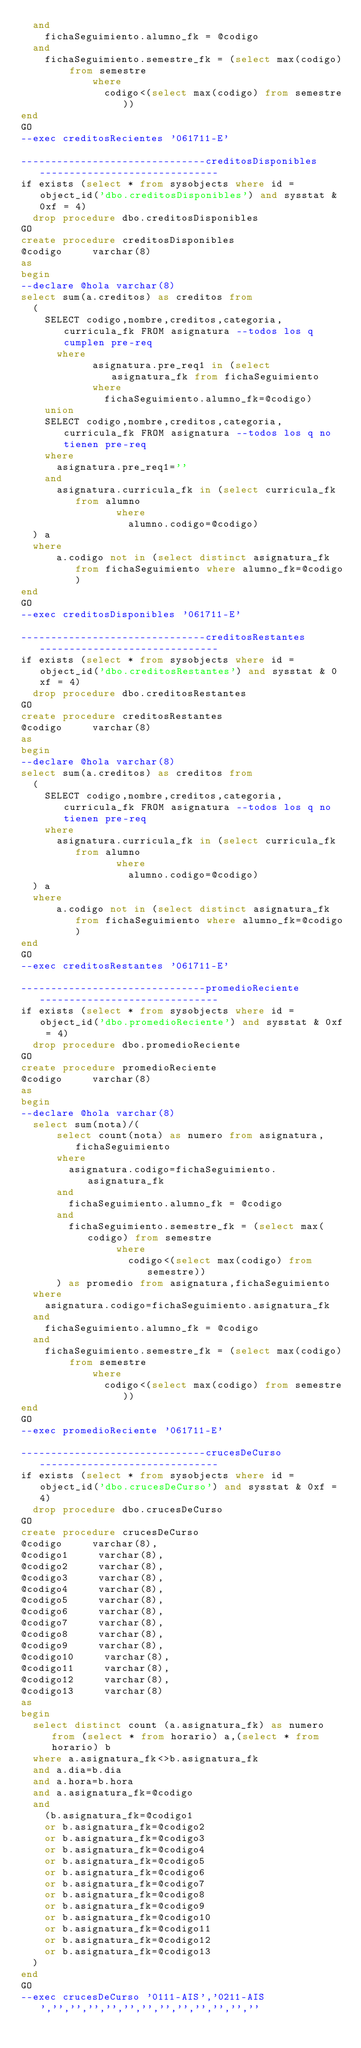Convert code to text. <code><loc_0><loc_0><loc_500><loc_500><_SQL_>	and 
		fichaSeguimiento.alumno_fk = @codigo
	and
		fichaSeguimiento.semestre_fk = (select max(codigo) from semestre
						where 
							codigo<(select max(codigo) from semestre))
end
GO
--exec creditosRecientes '061711-E'

-------------------------------creditosDisponibles------------------------------
if exists (select * from sysobjects where id = object_id('dbo.creditosDisponibles') and sysstat & 0xf = 4) 
  drop procedure dbo.creditosDisponibles
GO
create procedure creditosDisponibles
@codigo     varchar(8)
as
begin
--declare @hola varchar(8)
select sum(a.creditos) as creditos from 
	(
		SELECT codigo,nombre,creditos,categoria,curricula_fk FROM asignatura --todos los q cumplen pre-req
  		where 
        		asignatura.pre_req1 in (select asignatura_fk from fichaSeguimiento
						where
							fichaSeguimiento.alumno_fk=@codigo)
		union
		SELECT codigo,nombre,creditos,categoria,curricula_fk FROM asignatura --todos los q no tienen pre-req
		where 
			asignatura.pre_req1='' 
		and 
			asignatura.curricula_fk in (select curricula_fk from alumno
						    where
						    	alumno.codigo=@codigo)
	) a
	where
  		a.codigo not in (select distinct asignatura_fk from fichaSeguimiento where alumno_fk=@codigo)
end
GO
--exec creditosDisponibles '061711-E'

-------------------------------creditosRestantes------------------------------
if exists (select * from sysobjects where id = object_id('dbo.creditosRestantes') and sysstat & 0xf = 4) 
  drop procedure dbo.creditosRestantes
GO
create procedure creditosRestantes
@codigo     varchar(8)
as
begin
--declare @hola varchar(8)
select sum(a.creditos) as creditos from 
	(
		SELECT codigo,nombre,creditos,categoria,curricula_fk FROM asignatura --todos los q no tienen pre-req
		where
			asignatura.curricula_fk in (select curricula_fk from alumno
						    where
						    	alumno.codigo=@codigo)
	) a
	where
  		a.codigo not in (select distinct asignatura_fk from fichaSeguimiento where alumno_fk=@codigo)
end
GO
--exec creditosRestantes '061711-E'

-------------------------------promedioReciente------------------------------
if exists (select * from sysobjects where id = object_id('dbo.promedioReciente') and sysstat & 0xf = 4) 
  drop procedure dbo.promedioReciente
GO
create procedure promedioReciente
@codigo     varchar(8)
as
begin
--declare @hola varchar(8)
	select sum(nota)/(
			select count(nota) as numero from asignatura,fichaSeguimiento 
			where 
				asignatura.codigo=fichaSeguimiento.asignatura_fk 
			and 
				fichaSeguimiento.alumno_fk = @codigo
			and
				fichaSeguimiento.semestre_fk = (select max(codigo) from semestre
								where 
									codigo<(select max(codigo) from semestre))
			) as promedio from asignatura,fichaSeguimiento 
	where 
		asignatura.codigo=fichaSeguimiento.asignatura_fk 
	and 
		fichaSeguimiento.alumno_fk = @codigo
	and
		fichaSeguimiento.semestre_fk = (select max(codigo) from semestre
						where 
							codigo<(select max(codigo) from semestre))
end
GO
--exec promedioReciente '061711-E'

-------------------------------crucesDeCurso------------------------------
if exists (select * from sysobjects where id = object_id('dbo.crucesDeCurso') and sysstat & 0xf = 4) 
  drop procedure dbo.crucesDeCurso
GO
create procedure crucesDeCurso
@codigo     varchar(8),
@codigo1     varchar(8),
@codigo2     varchar(8),
@codigo3     varchar(8),
@codigo4     varchar(8),
@codigo5     varchar(8),
@codigo6     varchar(8),
@codigo7     varchar(8),
@codigo8     varchar(8),
@codigo9     varchar(8),
@codigo10     varchar(8),
@codigo11     varchar(8),
@codigo12     varchar(8),
@codigo13     varchar(8)
as
begin
	select distinct count (a.asignatura_fk) as numero from (select * from horario) a,(select * from horario) b
	where a.asignatura_fk<>b.asignatura_fk
	and a.dia=b.dia
	and a.hora=b.hora
	and a.asignatura_fk=@codigo
	and 
		(b.asignatura_fk=@codigo1
		or b.asignatura_fk=@codigo2
		or b.asignatura_fk=@codigo3
		or b.asignatura_fk=@codigo4
		or b.asignatura_fk=@codigo5
		or b.asignatura_fk=@codigo6
		or b.asignatura_fk=@codigo7
		or b.asignatura_fk=@codigo8
		or b.asignatura_fk=@codigo9
		or b.asignatura_fk=@codigo10
		or b.asignatura_fk=@codigo11
		or b.asignatura_fk=@codigo12
		or b.asignatura_fk=@codigo13
	)
end
GO
--exec crucesDeCurso '0111-AIS','0211-AIS','','','','','','','','','','','',''</code> 